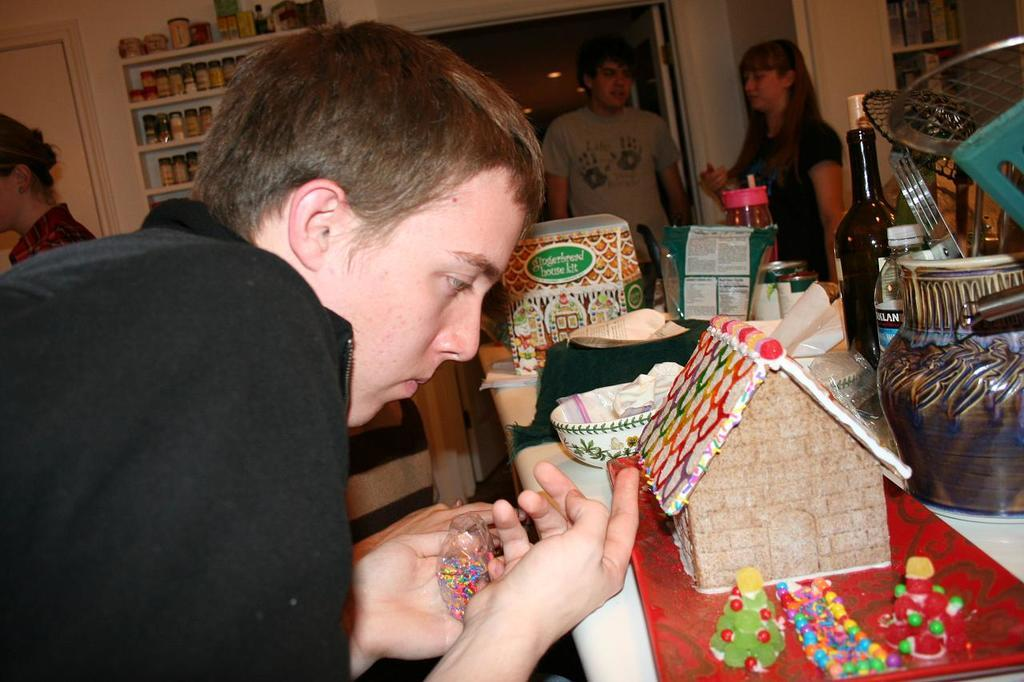What is the man in the image doing? The man is preparing a toy house. Are there any other people in the image? Yes, there are two people standing and talking to each other. What type of hospital equipment can be seen in the image? There is no hospital equipment present in the image. What part of the toy house is the man currently working on? The provided facts do not specify which part of the toy house the man is working on. 